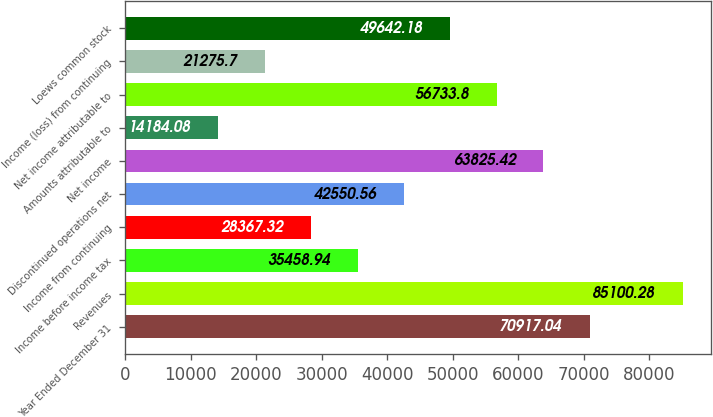<chart> <loc_0><loc_0><loc_500><loc_500><bar_chart><fcel>Year Ended December 31<fcel>Revenues<fcel>Income before income tax<fcel>Income from continuing<fcel>Discontinued operations net<fcel>Net income<fcel>Amounts attributable to<fcel>Net income attributable to<fcel>Income (loss) from continuing<fcel>Loews common stock<nl><fcel>70917<fcel>85100.3<fcel>35458.9<fcel>28367.3<fcel>42550.6<fcel>63825.4<fcel>14184.1<fcel>56733.8<fcel>21275.7<fcel>49642.2<nl></chart> 